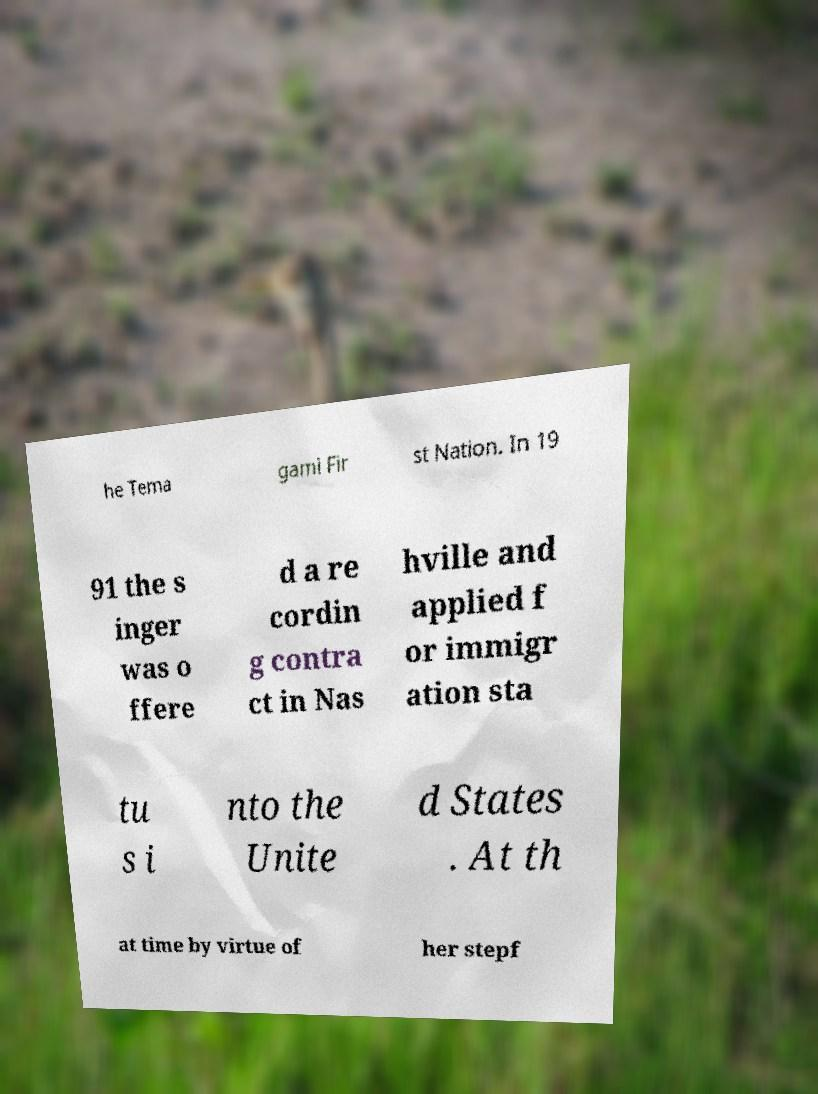Can you read and provide the text displayed in the image?This photo seems to have some interesting text. Can you extract and type it out for me? he Tema gami Fir st Nation. In 19 91 the s inger was o ffere d a re cordin g contra ct in Nas hville and applied f or immigr ation sta tu s i nto the Unite d States . At th at time by virtue of her stepf 